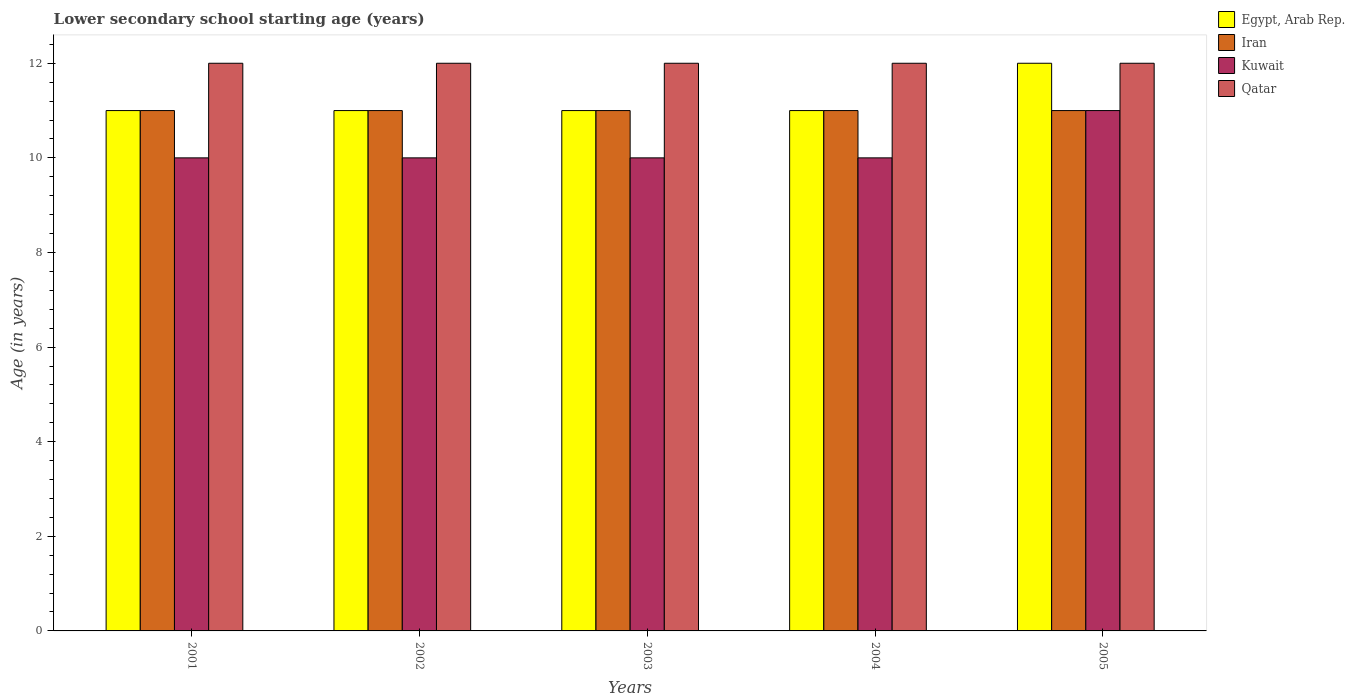What is the label of the 2nd group of bars from the left?
Keep it short and to the point. 2002. In how many cases, is the number of bars for a given year not equal to the number of legend labels?
Give a very brief answer. 0. What is the lower secondary school starting age of children in Egypt, Arab Rep. in 2002?
Your answer should be compact. 11. Across all years, what is the maximum lower secondary school starting age of children in Egypt, Arab Rep.?
Ensure brevity in your answer.  12. Across all years, what is the minimum lower secondary school starting age of children in Iran?
Make the answer very short. 11. In which year was the lower secondary school starting age of children in Iran maximum?
Provide a short and direct response. 2001. In which year was the lower secondary school starting age of children in Kuwait minimum?
Give a very brief answer. 2001. What is the total lower secondary school starting age of children in Qatar in the graph?
Keep it short and to the point. 60. What is the difference between the lower secondary school starting age of children in Kuwait in 2005 and the lower secondary school starting age of children in Qatar in 2001?
Your response must be concise. -1. In the year 2004, what is the difference between the lower secondary school starting age of children in Qatar and lower secondary school starting age of children in Iran?
Your response must be concise. 1. In how many years, is the lower secondary school starting age of children in Kuwait greater than 7.2 years?
Offer a terse response. 5. What is the ratio of the lower secondary school starting age of children in Iran in 2002 to that in 2005?
Offer a terse response. 1. Is the lower secondary school starting age of children in Iran in 2001 less than that in 2005?
Ensure brevity in your answer.  No. What is the difference between the highest and the lowest lower secondary school starting age of children in Iran?
Offer a terse response. 0. What does the 4th bar from the left in 2004 represents?
Ensure brevity in your answer.  Qatar. What does the 1st bar from the right in 2001 represents?
Provide a short and direct response. Qatar. Are all the bars in the graph horizontal?
Ensure brevity in your answer.  No. How many years are there in the graph?
Provide a succinct answer. 5. What is the difference between two consecutive major ticks on the Y-axis?
Your response must be concise. 2. Does the graph contain any zero values?
Provide a succinct answer. No. Does the graph contain grids?
Provide a succinct answer. No. How are the legend labels stacked?
Your answer should be compact. Vertical. What is the title of the graph?
Make the answer very short. Lower secondary school starting age (years). Does "Latin America(developing only)" appear as one of the legend labels in the graph?
Keep it short and to the point. No. What is the label or title of the X-axis?
Make the answer very short. Years. What is the label or title of the Y-axis?
Your answer should be very brief. Age (in years). What is the Age (in years) in Egypt, Arab Rep. in 2001?
Offer a terse response. 11. What is the Age (in years) in Iran in 2001?
Your answer should be very brief. 11. What is the Age (in years) in Kuwait in 2001?
Ensure brevity in your answer.  10. What is the Age (in years) of Kuwait in 2002?
Your response must be concise. 10. What is the Age (in years) in Egypt, Arab Rep. in 2003?
Offer a very short reply. 11. What is the Age (in years) of Qatar in 2003?
Make the answer very short. 12. What is the Age (in years) in Egypt, Arab Rep. in 2004?
Offer a terse response. 11. What is the Age (in years) in Iran in 2004?
Your response must be concise. 11. What is the Age (in years) in Kuwait in 2004?
Offer a terse response. 10. What is the Age (in years) of Qatar in 2004?
Your answer should be compact. 12. What is the Age (in years) of Egypt, Arab Rep. in 2005?
Give a very brief answer. 12. What is the Age (in years) in Iran in 2005?
Ensure brevity in your answer.  11. What is the Age (in years) in Kuwait in 2005?
Your response must be concise. 11. What is the Age (in years) in Qatar in 2005?
Your answer should be compact. 12. Across all years, what is the maximum Age (in years) in Egypt, Arab Rep.?
Your response must be concise. 12. Across all years, what is the maximum Age (in years) of Qatar?
Provide a short and direct response. 12. Across all years, what is the minimum Age (in years) of Iran?
Give a very brief answer. 11. What is the total Age (in years) in Iran in the graph?
Offer a very short reply. 55. What is the total Age (in years) of Kuwait in the graph?
Your answer should be compact. 51. What is the difference between the Age (in years) in Egypt, Arab Rep. in 2001 and that in 2002?
Keep it short and to the point. 0. What is the difference between the Age (in years) of Kuwait in 2001 and that in 2002?
Ensure brevity in your answer.  0. What is the difference between the Age (in years) in Qatar in 2001 and that in 2002?
Offer a very short reply. 0. What is the difference between the Age (in years) of Egypt, Arab Rep. in 2001 and that in 2003?
Keep it short and to the point. 0. What is the difference between the Age (in years) of Kuwait in 2001 and that in 2003?
Ensure brevity in your answer.  0. What is the difference between the Age (in years) in Qatar in 2001 and that in 2003?
Your answer should be compact. 0. What is the difference between the Age (in years) of Egypt, Arab Rep. in 2001 and that in 2004?
Provide a short and direct response. 0. What is the difference between the Age (in years) in Iran in 2001 and that in 2004?
Your answer should be very brief. 0. What is the difference between the Age (in years) of Qatar in 2001 and that in 2004?
Provide a short and direct response. 0. What is the difference between the Age (in years) in Iran in 2001 and that in 2005?
Keep it short and to the point. 0. What is the difference between the Age (in years) in Kuwait in 2001 and that in 2005?
Make the answer very short. -1. What is the difference between the Age (in years) of Qatar in 2001 and that in 2005?
Offer a terse response. 0. What is the difference between the Age (in years) in Iran in 2002 and that in 2003?
Keep it short and to the point. 0. What is the difference between the Age (in years) of Qatar in 2002 and that in 2003?
Give a very brief answer. 0. What is the difference between the Age (in years) of Egypt, Arab Rep. in 2002 and that in 2004?
Make the answer very short. 0. What is the difference between the Age (in years) in Iran in 2002 and that in 2004?
Your response must be concise. 0. What is the difference between the Age (in years) in Egypt, Arab Rep. in 2002 and that in 2005?
Offer a very short reply. -1. What is the difference between the Age (in years) in Iran in 2002 and that in 2005?
Provide a succinct answer. 0. What is the difference between the Age (in years) in Qatar in 2002 and that in 2005?
Offer a very short reply. 0. What is the difference between the Age (in years) of Egypt, Arab Rep. in 2003 and that in 2004?
Your response must be concise. 0. What is the difference between the Age (in years) in Iran in 2003 and that in 2004?
Give a very brief answer. 0. What is the difference between the Age (in years) of Kuwait in 2003 and that in 2004?
Give a very brief answer. 0. What is the difference between the Age (in years) in Qatar in 2003 and that in 2004?
Your answer should be very brief. 0. What is the difference between the Age (in years) in Egypt, Arab Rep. in 2003 and that in 2005?
Your answer should be compact. -1. What is the difference between the Age (in years) in Iran in 2003 and that in 2005?
Make the answer very short. 0. What is the difference between the Age (in years) of Qatar in 2004 and that in 2005?
Keep it short and to the point. 0. What is the difference between the Age (in years) in Egypt, Arab Rep. in 2001 and the Age (in years) in Iran in 2002?
Offer a very short reply. 0. What is the difference between the Age (in years) in Egypt, Arab Rep. in 2001 and the Age (in years) in Kuwait in 2002?
Offer a very short reply. 1. What is the difference between the Age (in years) of Egypt, Arab Rep. in 2001 and the Age (in years) of Kuwait in 2003?
Provide a succinct answer. 1. What is the difference between the Age (in years) of Iran in 2001 and the Age (in years) of Kuwait in 2003?
Offer a very short reply. 1. What is the difference between the Age (in years) of Kuwait in 2001 and the Age (in years) of Qatar in 2003?
Ensure brevity in your answer.  -2. What is the difference between the Age (in years) of Egypt, Arab Rep. in 2001 and the Age (in years) of Kuwait in 2004?
Your answer should be compact. 1. What is the difference between the Age (in years) in Kuwait in 2001 and the Age (in years) in Qatar in 2004?
Provide a short and direct response. -2. What is the difference between the Age (in years) in Egypt, Arab Rep. in 2001 and the Age (in years) in Iran in 2005?
Provide a succinct answer. 0. What is the difference between the Age (in years) of Egypt, Arab Rep. in 2001 and the Age (in years) of Kuwait in 2005?
Provide a succinct answer. 0. What is the difference between the Age (in years) in Egypt, Arab Rep. in 2001 and the Age (in years) in Qatar in 2005?
Offer a terse response. -1. What is the difference between the Age (in years) of Iran in 2001 and the Age (in years) of Kuwait in 2005?
Make the answer very short. 0. What is the difference between the Age (in years) in Iran in 2001 and the Age (in years) in Qatar in 2005?
Keep it short and to the point. -1. What is the difference between the Age (in years) of Egypt, Arab Rep. in 2002 and the Age (in years) of Kuwait in 2003?
Make the answer very short. 1. What is the difference between the Age (in years) of Egypt, Arab Rep. in 2002 and the Age (in years) of Qatar in 2003?
Keep it short and to the point. -1. What is the difference between the Age (in years) in Iran in 2002 and the Age (in years) in Kuwait in 2003?
Offer a terse response. 1. What is the difference between the Age (in years) of Iran in 2002 and the Age (in years) of Qatar in 2003?
Provide a succinct answer. -1. What is the difference between the Age (in years) in Egypt, Arab Rep. in 2002 and the Age (in years) in Qatar in 2004?
Keep it short and to the point. -1. What is the difference between the Age (in years) of Iran in 2002 and the Age (in years) of Kuwait in 2004?
Give a very brief answer. 1. What is the difference between the Age (in years) of Iran in 2002 and the Age (in years) of Qatar in 2004?
Your answer should be compact. -1. What is the difference between the Age (in years) in Egypt, Arab Rep. in 2002 and the Age (in years) in Iran in 2005?
Ensure brevity in your answer.  0. What is the difference between the Age (in years) of Egypt, Arab Rep. in 2002 and the Age (in years) of Qatar in 2005?
Provide a short and direct response. -1. What is the difference between the Age (in years) in Iran in 2002 and the Age (in years) in Kuwait in 2005?
Your answer should be very brief. 0. What is the difference between the Age (in years) of Iran in 2002 and the Age (in years) of Qatar in 2005?
Keep it short and to the point. -1. What is the difference between the Age (in years) in Kuwait in 2002 and the Age (in years) in Qatar in 2005?
Your answer should be very brief. -2. What is the difference between the Age (in years) of Egypt, Arab Rep. in 2003 and the Age (in years) of Iran in 2004?
Provide a short and direct response. 0. What is the difference between the Age (in years) of Egypt, Arab Rep. in 2003 and the Age (in years) of Qatar in 2004?
Provide a succinct answer. -1. What is the difference between the Age (in years) of Iran in 2003 and the Age (in years) of Qatar in 2004?
Keep it short and to the point. -1. What is the difference between the Age (in years) of Kuwait in 2003 and the Age (in years) of Qatar in 2004?
Offer a terse response. -2. What is the difference between the Age (in years) in Egypt, Arab Rep. in 2003 and the Age (in years) in Kuwait in 2005?
Make the answer very short. 0. What is the difference between the Age (in years) in Egypt, Arab Rep. in 2003 and the Age (in years) in Qatar in 2005?
Your response must be concise. -1. What is the difference between the Age (in years) in Iran in 2003 and the Age (in years) in Kuwait in 2005?
Offer a terse response. 0. What is the difference between the Age (in years) of Egypt, Arab Rep. in 2004 and the Age (in years) of Iran in 2005?
Make the answer very short. 0. What is the difference between the Age (in years) in Egypt, Arab Rep. in 2004 and the Age (in years) in Kuwait in 2005?
Provide a short and direct response. 0. What is the difference between the Age (in years) in Egypt, Arab Rep. in 2004 and the Age (in years) in Qatar in 2005?
Provide a short and direct response. -1. What is the difference between the Age (in years) in Iran in 2004 and the Age (in years) in Qatar in 2005?
Keep it short and to the point. -1. What is the difference between the Age (in years) in Kuwait in 2004 and the Age (in years) in Qatar in 2005?
Your response must be concise. -2. What is the average Age (in years) in Iran per year?
Offer a very short reply. 11. What is the average Age (in years) of Kuwait per year?
Give a very brief answer. 10.2. What is the average Age (in years) of Qatar per year?
Offer a terse response. 12. In the year 2001, what is the difference between the Age (in years) in Egypt, Arab Rep. and Age (in years) in Iran?
Offer a terse response. 0. In the year 2001, what is the difference between the Age (in years) of Egypt, Arab Rep. and Age (in years) of Qatar?
Keep it short and to the point. -1. In the year 2001, what is the difference between the Age (in years) in Iran and Age (in years) in Kuwait?
Your answer should be compact. 1. In the year 2001, what is the difference between the Age (in years) in Iran and Age (in years) in Qatar?
Your answer should be compact. -1. In the year 2001, what is the difference between the Age (in years) in Kuwait and Age (in years) in Qatar?
Give a very brief answer. -2. In the year 2002, what is the difference between the Age (in years) in Egypt, Arab Rep. and Age (in years) in Qatar?
Your answer should be compact. -1. In the year 2002, what is the difference between the Age (in years) in Iran and Age (in years) in Kuwait?
Ensure brevity in your answer.  1. In the year 2002, what is the difference between the Age (in years) in Iran and Age (in years) in Qatar?
Your answer should be compact. -1. In the year 2002, what is the difference between the Age (in years) in Kuwait and Age (in years) in Qatar?
Offer a terse response. -2. In the year 2003, what is the difference between the Age (in years) of Egypt, Arab Rep. and Age (in years) of Kuwait?
Keep it short and to the point. 1. In the year 2003, what is the difference between the Age (in years) of Egypt, Arab Rep. and Age (in years) of Qatar?
Your response must be concise. -1. In the year 2003, what is the difference between the Age (in years) of Iran and Age (in years) of Qatar?
Your response must be concise. -1. In the year 2003, what is the difference between the Age (in years) of Kuwait and Age (in years) of Qatar?
Provide a short and direct response. -2. In the year 2004, what is the difference between the Age (in years) of Egypt, Arab Rep. and Age (in years) of Qatar?
Make the answer very short. -1. In the year 2004, what is the difference between the Age (in years) of Iran and Age (in years) of Kuwait?
Offer a terse response. 1. In the year 2004, what is the difference between the Age (in years) in Iran and Age (in years) in Qatar?
Make the answer very short. -1. In the year 2004, what is the difference between the Age (in years) in Kuwait and Age (in years) in Qatar?
Your answer should be very brief. -2. In the year 2005, what is the difference between the Age (in years) of Egypt, Arab Rep. and Age (in years) of Iran?
Ensure brevity in your answer.  1. In the year 2005, what is the difference between the Age (in years) in Egypt, Arab Rep. and Age (in years) in Kuwait?
Ensure brevity in your answer.  1. In the year 2005, what is the difference between the Age (in years) in Iran and Age (in years) in Qatar?
Your answer should be compact. -1. In the year 2005, what is the difference between the Age (in years) in Kuwait and Age (in years) in Qatar?
Your answer should be compact. -1. What is the ratio of the Age (in years) in Egypt, Arab Rep. in 2001 to that in 2002?
Offer a very short reply. 1. What is the ratio of the Age (in years) of Iran in 2001 to that in 2002?
Ensure brevity in your answer.  1. What is the ratio of the Age (in years) in Kuwait in 2001 to that in 2002?
Offer a very short reply. 1. What is the ratio of the Age (in years) of Qatar in 2001 to that in 2002?
Your response must be concise. 1. What is the ratio of the Age (in years) in Kuwait in 2001 to that in 2003?
Offer a very short reply. 1. What is the ratio of the Age (in years) of Iran in 2001 to that in 2005?
Your answer should be compact. 1. What is the ratio of the Age (in years) in Kuwait in 2001 to that in 2005?
Offer a terse response. 0.91. What is the ratio of the Age (in years) in Qatar in 2001 to that in 2005?
Your answer should be compact. 1. What is the ratio of the Age (in years) of Egypt, Arab Rep. in 2002 to that in 2003?
Give a very brief answer. 1. What is the ratio of the Age (in years) in Iran in 2002 to that in 2003?
Your answer should be very brief. 1. What is the ratio of the Age (in years) of Kuwait in 2002 to that in 2003?
Ensure brevity in your answer.  1. What is the ratio of the Age (in years) in Qatar in 2002 to that in 2003?
Keep it short and to the point. 1. What is the ratio of the Age (in years) of Iran in 2002 to that in 2004?
Provide a succinct answer. 1. What is the ratio of the Age (in years) in Qatar in 2002 to that in 2004?
Provide a short and direct response. 1. What is the ratio of the Age (in years) of Egypt, Arab Rep. in 2003 to that in 2004?
Make the answer very short. 1. What is the ratio of the Age (in years) in Kuwait in 2003 to that in 2004?
Provide a succinct answer. 1. What is the ratio of the Age (in years) in Qatar in 2003 to that in 2004?
Give a very brief answer. 1. What is the ratio of the Age (in years) of Iran in 2003 to that in 2005?
Provide a succinct answer. 1. What is the ratio of the Age (in years) of Kuwait in 2003 to that in 2005?
Your answer should be very brief. 0.91. What is the ratio of the Age (in years) in Qatar in 2003 to that in 2005?
Ensure brevity in your answer.  1. What is the ratio of the Age (in years) in Iran in 2004 to that in 2005?
Your answer should be very brief. 1. What is the ratio of the Age (in years) of Kuwait in 2004 to that in 2005?
Provide a short and direct response. 0.91. What is the difference between the highest and the second highest Age (in years) in Kuwait?
Offer a terse response. 1. What is the difference between the highest and the second highest Age (in years) of Qatar?
Keep it short and to the point. 0. What is the difference between the highest and the lowest Age (in years) of Iran?
Make the answer very short. 0. What is the difference between the highest and the lowest Age (in years) of Kuwait?
Offer a terse response. 1. 